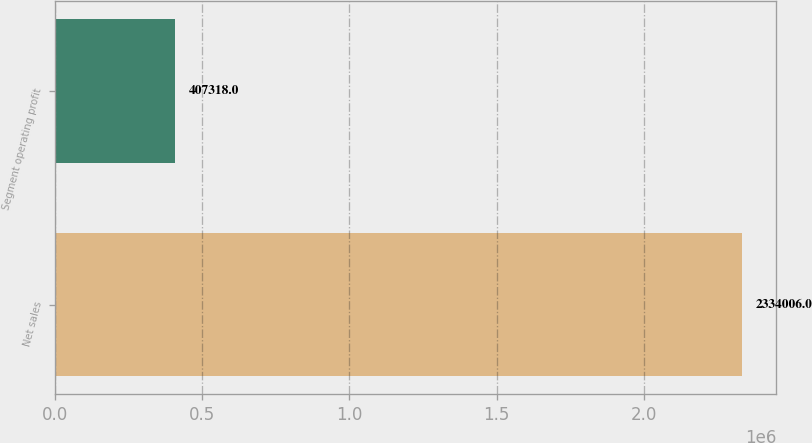Convert chart. <chart><loc_0><loc_0><loc_500><loc_500><bar_chart><fcel>Net sales<fcel>Segment operating profit<nl><fcel>2.33401e+06<fcel>407318<nl></chart> 